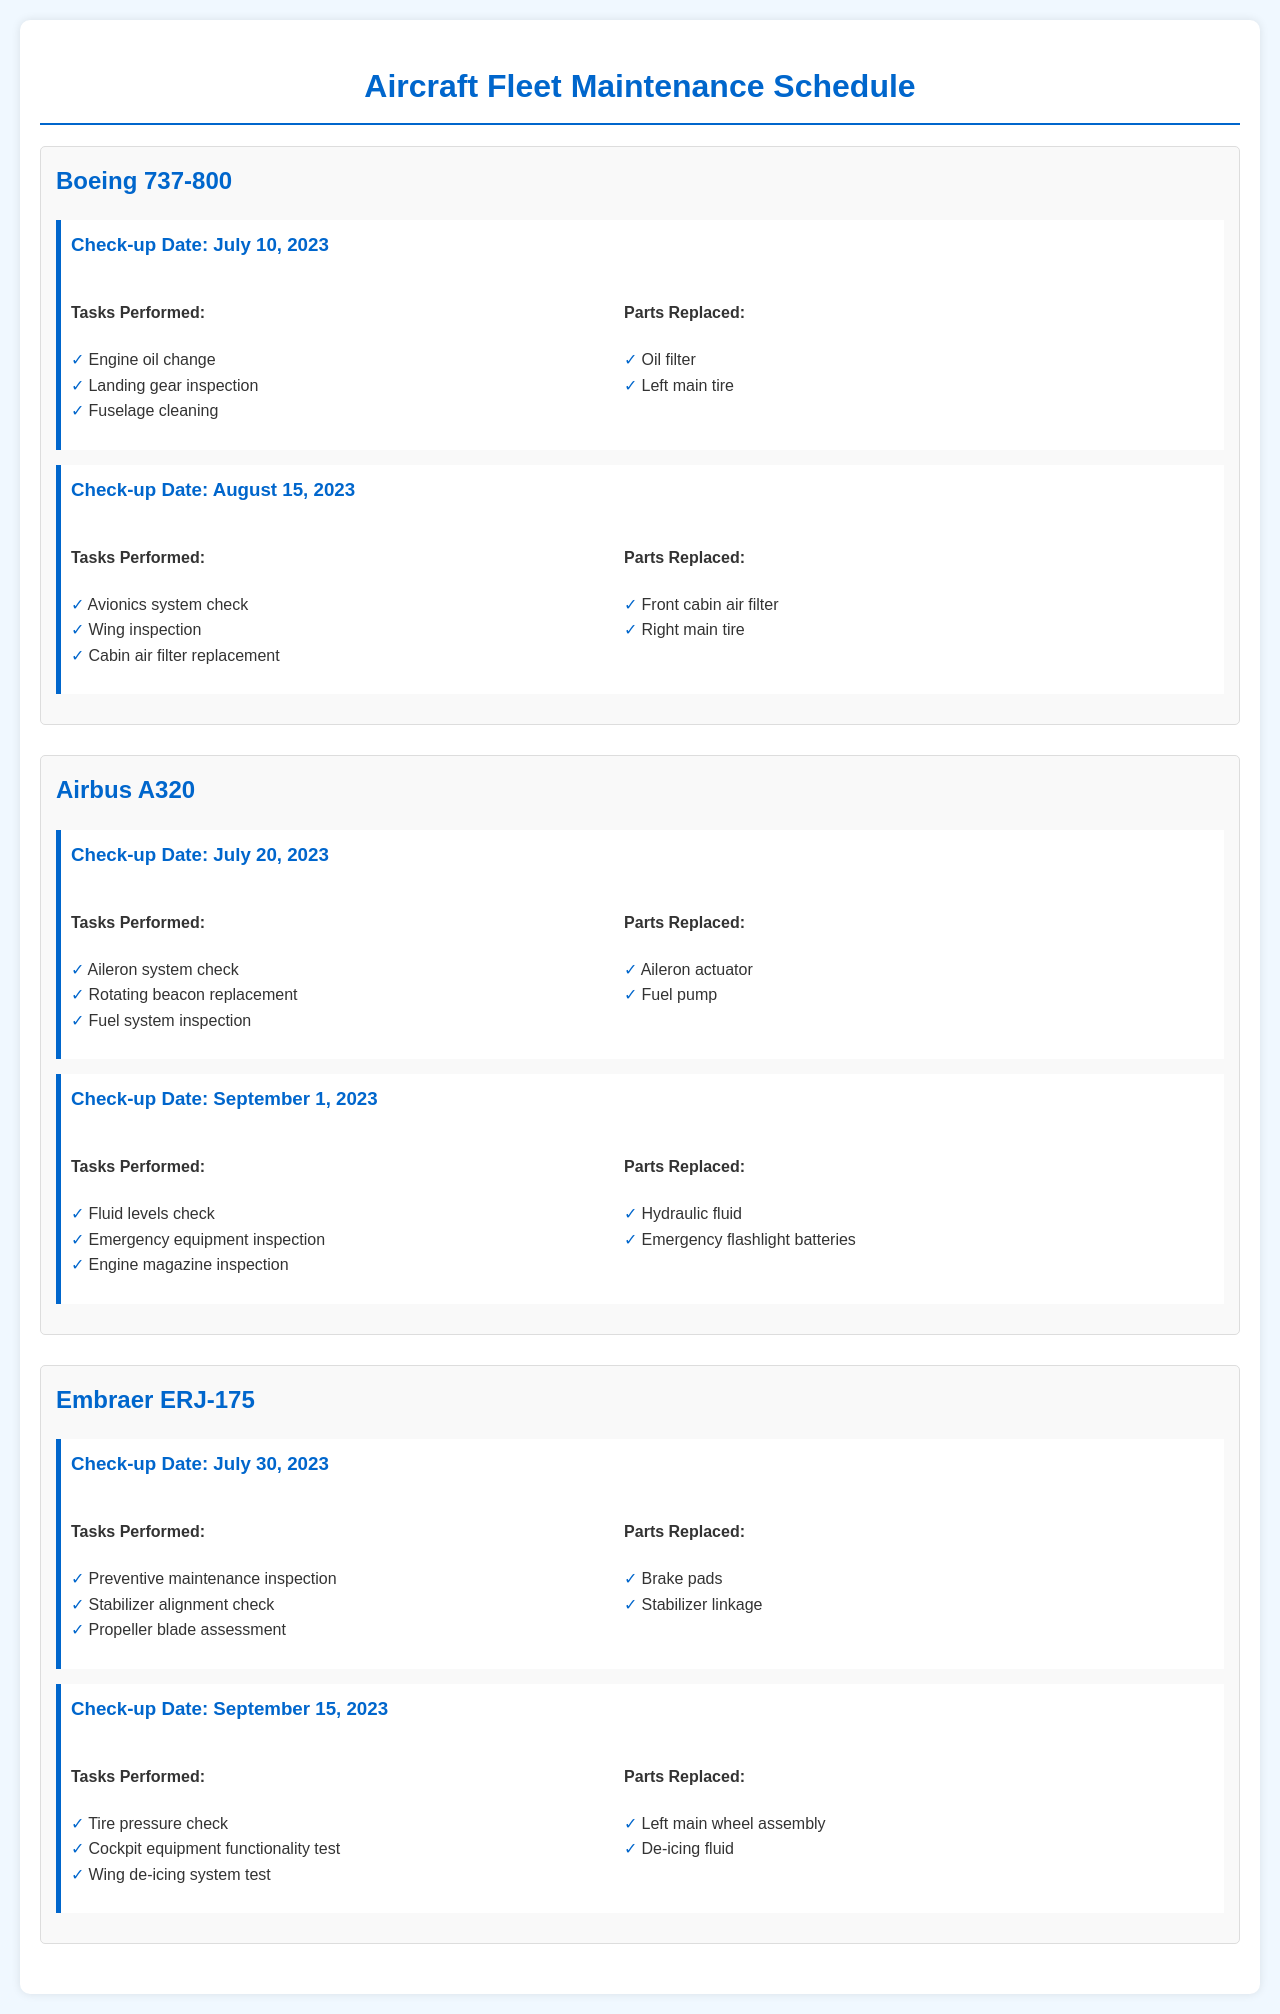What is the check-up date for the Boeing 737-800? The check-up date for the Boeing 737-800 is found in the document, listed as July 10, 2023 and August 15, 2023.
Answer: July 10, 2023 What tasks were performed during the check-up on August 15, 2023? The tasks performed on August 15, 2023 for the Boeing 737-800 are listed in the section under that date.
Answer: Avionics system check, Wing inspection, Cabin air filter replacement Which parts were replaced for the Airbus A320 on September 1, 2023? The parts replaced are detailed in the document for the check-up on September 1, 2023 for the Airbus A320.
Answer: Hydraulic fluid, Emergency flashlight batteries How many aircraft had check-ups in July 2023? The document lists all aircraft check-ups, including two events in July 2023 for three aircraft.
Answer: Three What maintenance tasks were performed for the Embraer ERJ-175 on July 30, 2023? The document lists the specific tasks performed for the Embraer ERJ-175 during that check-up.
Answer: Preventive maintenance inspection, Stabilizer alignment check, Propeller blade assessment Which aircraft received a landing gear inspection as part of its maintenance? The landing gear inspection is found under the tasks performed for the Boeing 737-800 in the document.
Answer: Boeing 737-800 What was the check-up date for the Airbus A320? The check-up dates can be found in the aircraft section of the document for the Airbus A320.
Answer: July 20, 2023 and September 1, 2023 What parts were replaced on September 15, 2023, for the Embraer ERJ-175? The parts replaced on that date are detailed under the respective check-up section for the Embraer ERJ-175.
Answer: Left main wheel assembly, De-icing fluid How many total tasks were performed during the check-up of the Airbus A320 on July 20, 2023? The document lists the number of tasks performed during that check-up, which can be counted.
Answer: Three 